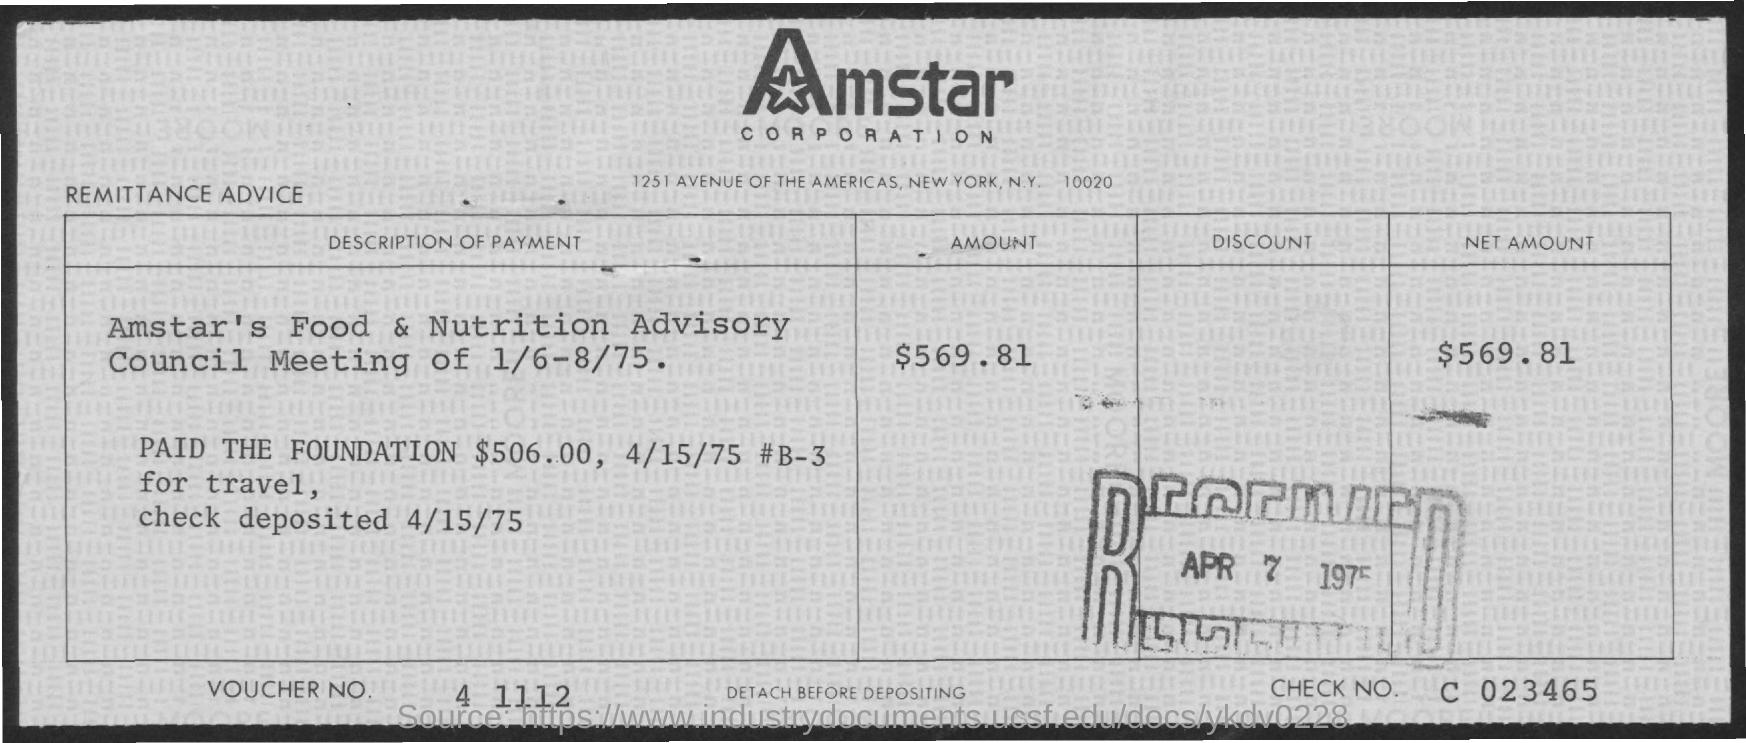Highlight a few significant elements in this photo. The remittance advice slip indicates that the check was deposited on April 15, 1975. The document mentions Amstar CORPORATION in its header. The net amount mentioned in the remittance advice slip is $569.81. The remittance advice slip contains a voucher number that is "What is the Voucher No. given in the remittance advice slip? 4 1112.. The check number provided in the remittance advice slip is C 023465. 